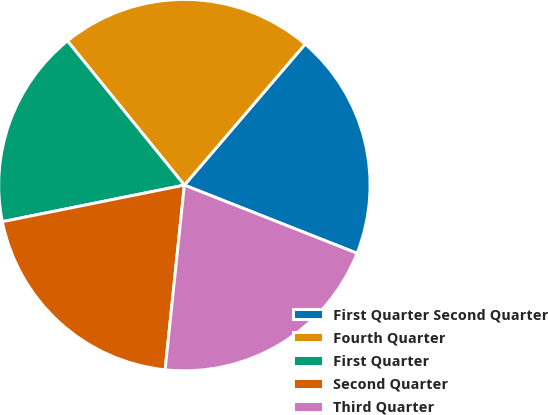Convert chart. <chart><loc_0><loc_0><loc_500><loc_500><pie_chart><fcel>First Quarter Second Quarter<fcel>Fourth Quarter<fcel>First Quarter<fcel>Second Quarter<fcel>Third Quarter<nl><fcel>19.71%<fcel>22.12%<fcel>17.31%<fcel>20.19%<fcel>20.67%<nl></chart> 